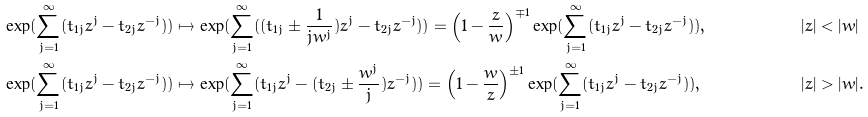Convert formula to latex. <formula><loc_0><loc_0><loc_500><loc_500>\exp ( \sum _ { j = 1 } ^ { \infty } ( t _ { 1 j } z ^ { j } - t _ { 2 j } z ^ { - j } ) ) & \mapsto \exp ( \sum _ { j = 1 } ^ { \infty } ( ( t _ { 1 j } \pm \frac { 1 } { j w ^ { j } } ) z ^ { j } - t _ { 2 j } z ^ { - j } ) ) = \left ( 1 - \frac { z } { w } \right ) ^ { \mp 1 } \exp ( \sum _ { j = 1 } ^ { \infty } ( t _ { 1 j } z ^ { j } - t _ { 2 j } z ^ { - j } ) ) , & | z | & < | w | \\ \exp ( \sum _ { j = 1 } ^ { \infty } ( t _ { 1 j } z ^ { j } - t _ { 2 j } z ^ { - j } ) ) & \mapsto \exp ( \sum _ { j = 1 } ^ { \infty } ( t _ { 1 j } z ^ { j } - ( t _ { 2 j } \pm \frac { w ^ { j } } { j } ) z ^ { - j } ) ) = \left ( 1 - \frac { w } { z } \right ) ^ { \pm 1 } \exp ( \sum _ { j = 1 } ^ { \infty } ( t _ { 1 j } z ^ { j } - t _ { 2 j } z ^ { - j } ) ) , & | z | & > | w | .</formula> 